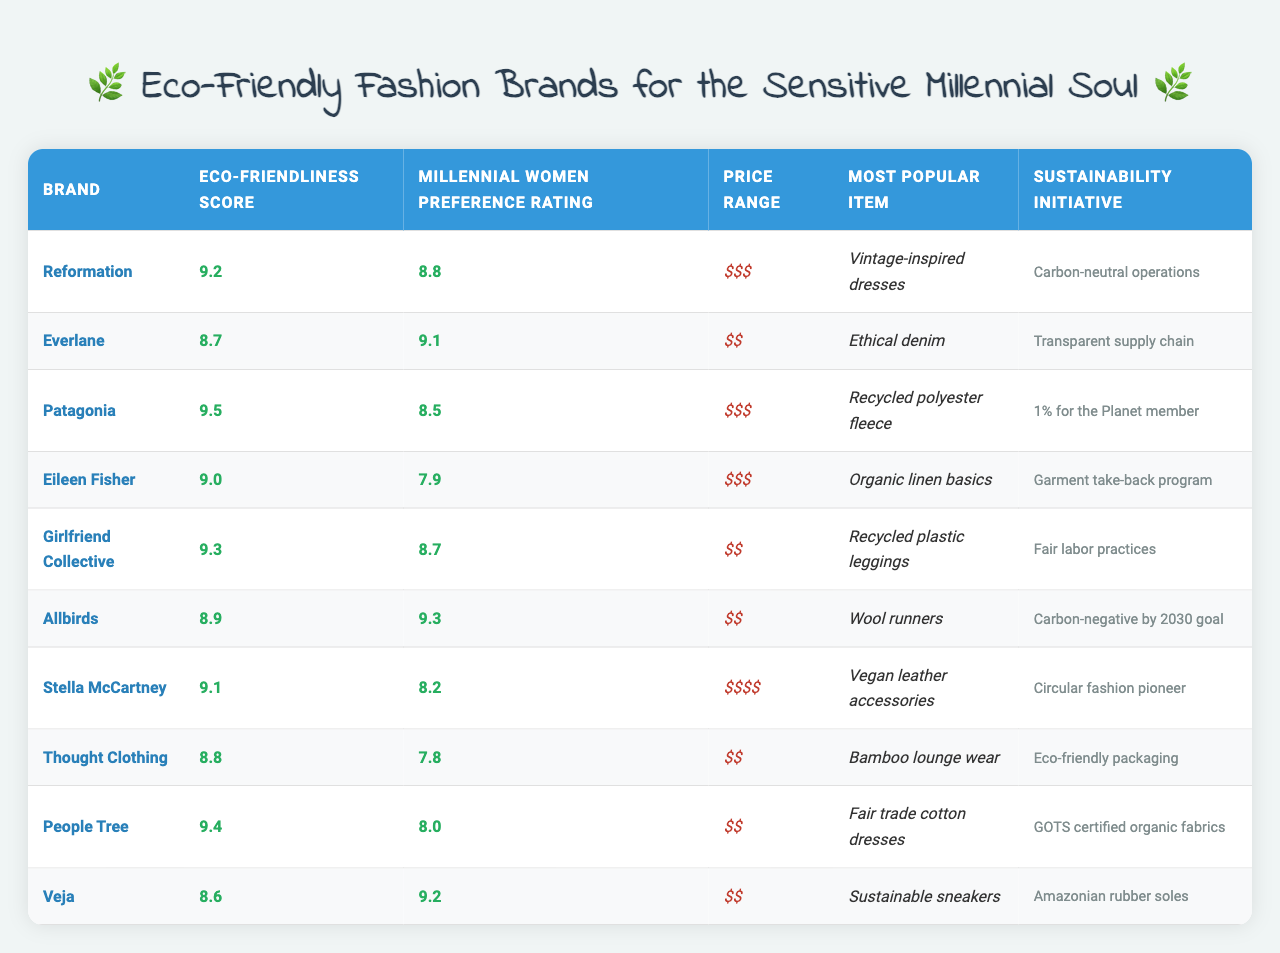What is the eco-friendliness score of Reformation? The eco-friendliness score for Reformation is listed in the table under the "Eco-Friendliness Score" column, which shows a value of 9.2.
Answer: 9.2 Which brand has the highest Millennial women preference rating? In the "Millennial Women Preference Rating" column, we can see that Allbirds has the highest rating at 9.3.
Answer: Allbirds Is Patagonia's price range considered expensive? Looking at the "Price Range" column, Patagonia is listed as "$$$", which suggests it is in the expensive range.
Answer: Yes What is the sustainability initiative of Everlane? By referring to the "Sustainability Initiative" column, it can be seen that Everlane's initiative is "Transparent supply chain."
Answer: Transparent supply chain Which brand offers vintage-inspired dresses? The "Most Popular Item" column indicates that Reformation offers "Vintage-inspired dresses."
Answer: Reformation What is the average eco-friendliness score of brands with a price range of "$$"? The eco-friendliness scores for brands with price range "$$" are Everlane (8.7), Girlfriend Collective (9.3), Allbirds (8.9), Thought Clothing (8.8), and Veja (8.6). Summing these scores gives 43.3. The average is 43.3/5 = 8.66.
Answer: 8.66 How many brands have a Millennial women preference rating above 8.5? The brands with a rating above 8.5 are Everlane (9.1), Allbirds (9.3), Girlfriend Collective (8.7), and Veja (9.2), totaling 4 brands.
Answer: 4 Does any brand have a sustainability initiative related to carbon neutrality? From the "Sustainability Initiative" column, we see that Reformation has "Carbon-neutral operations," confirming this fact.
Answer: Yes What is the difference between the highest and lowest preferring rating among brands? The highest rating is Allbirds at 9.3, and the lowest is Eileen Fisher at 7.9. The difference is 9.3 - 7.9 = 1.4.
Answer: 1.4 Which brands have eco-friendliness scores exceeding 9.0? The brands exceeding 9.0 are Patagonia (9.5), Reformation (9.2), and People Tree (9.4), giving a total of three brands.
Answer: 3 